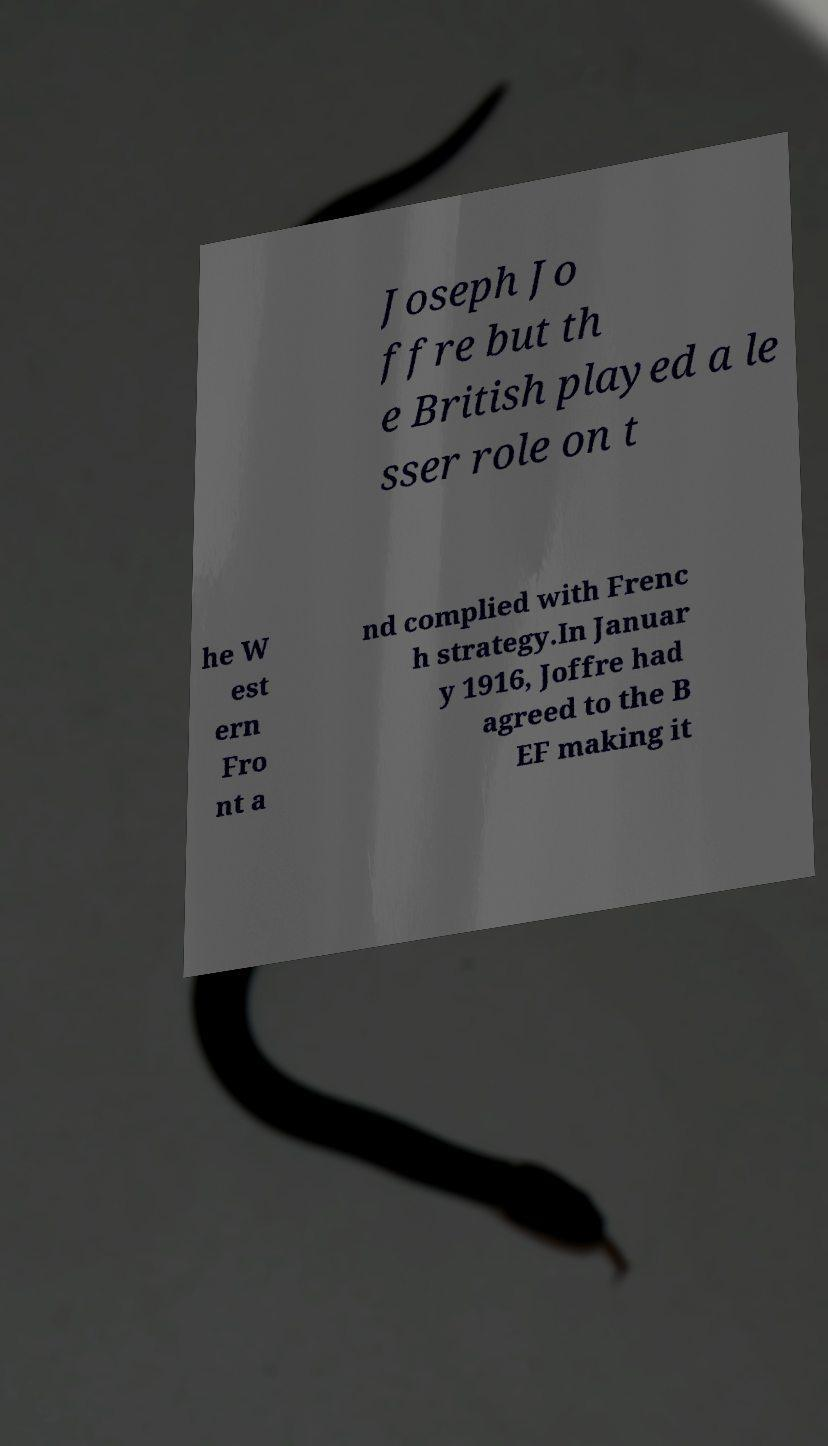Please read and relay the text visible in this image. What does it say? Joseph Jo ffre but th e British played a le sser role on t he W est ern Fro nt a nd complied with Frenc h strategy.In Januar y 1916, Joffre had agreed to the B EF making it 